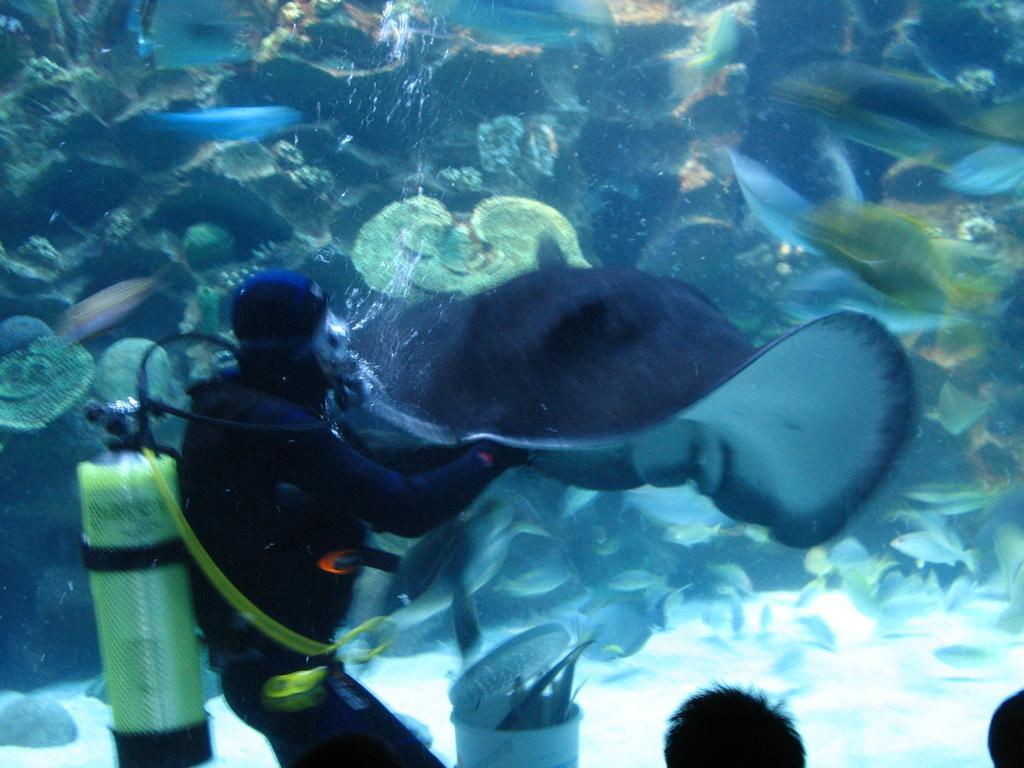Could you give a brief overview of what you see in this image? In this image we can see a person wearing a swimsuit and there is a fish in water and there are other water animals. At the bottom of the image there are two people. 